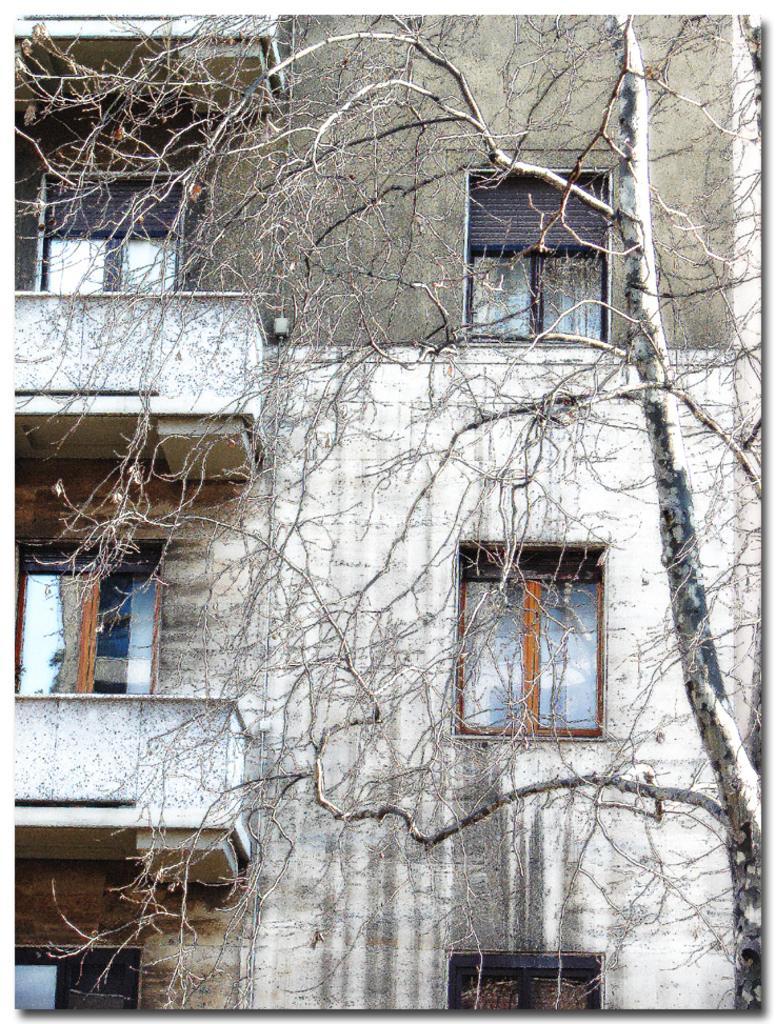How would you summarize this image in a sentence or two? In this picture I can see a dry tree behind which I can see building which is looking old. 